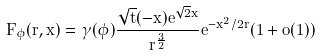<formula> <loc_0><loc_0><loc_500><loc_500>F _ { \phi } ( r , x ) = \gamma ( \phi ) \frac { \sqrt { t } ( - x ) e ^ { \sqrt { 2 } x } } { r ^ { \frac { 3 } { 2 } } } e ^ { - x ^ { 2 } / 2 r } ( 1 + o ( 1 ) )</formula> 